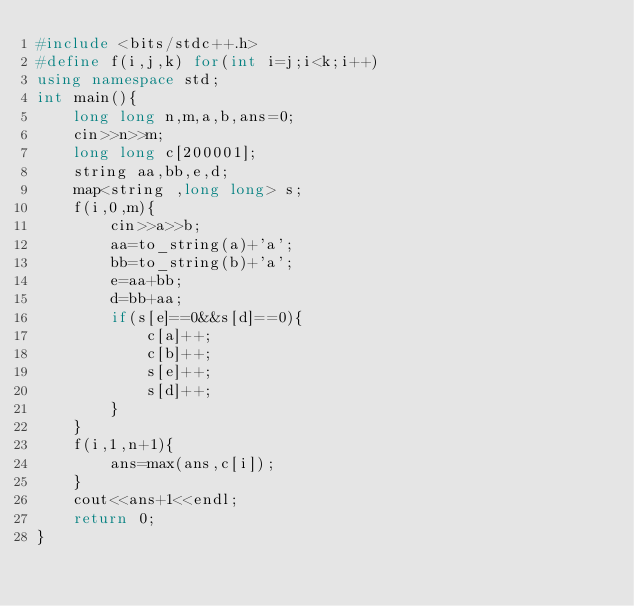<code> <loc_0><loc_0><loc_500><loc_500><_C++_>#include <bits/stdc++.h>
#define f(i,j,k) for(int i=j;i<k;i++)
using namespace std;
int main(){
    long long n,m,a,b,ans=0;
    cin>>n>>m;
    long long c[200001];
    string aa,bb,e,d;
    map<string ,long long> s;
    f(i,0,m){
        cin>>a>>b;
        aa=to_string(a)+'a';
        bb=to_string(b)+'a';
        e=aa+bb;
        d=bb+aa;
        if(s[e]==0&&s[d]==0){
            c[a]++;
            c[b]++;
            s[e]++;
            s[d]++;
        }
    }
    f(i,1,n+1){
        ans=max(ans,c[i]);
    }
    cout<<ans+1<<endl;
    return 0;
}
</code> 